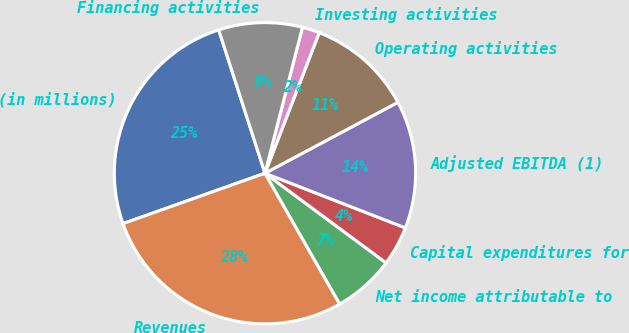<chart> <loc_0><loc_0><loc_500><loc_500><pie_chart><fcel>(in millions)<fcel>Revenues<fcel>Net income attributable to<fcel>Capital expenditures for<fcel>Adjusted EBITDA (1)<fcel>Operating activities<fcel>Investing activities<fcel>Financing activities<nl><fcel>25.46%<fcel>27.83%<fcel>6.6%<fcel>4.23%<fcel>13.71%<fcel>11.34%<fcel>1.86%<fcel>8.97%<nl></chart> 